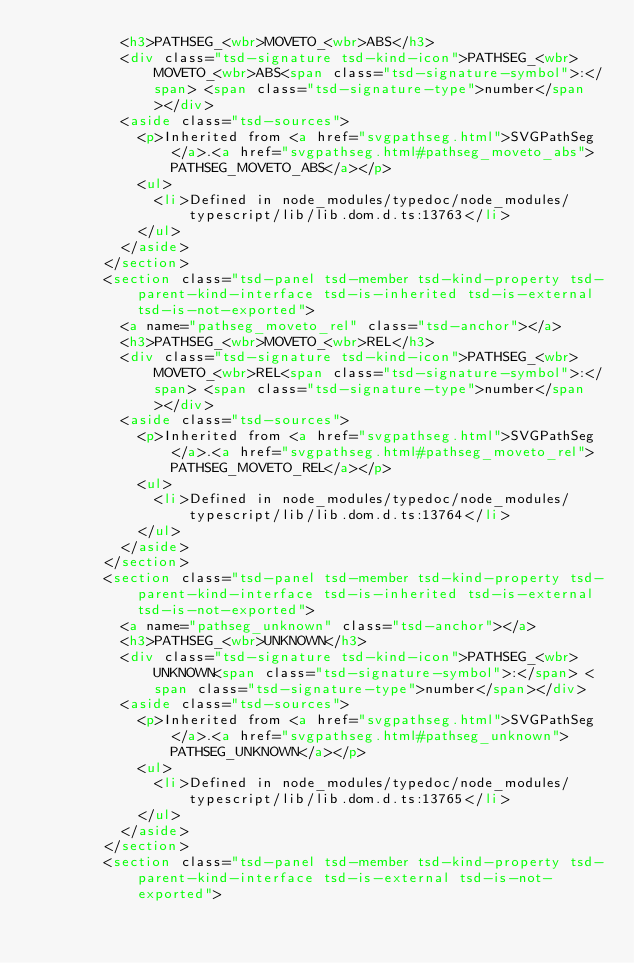Convert code to text. <code><loc_0><loc_0><loc_500><loc_500><_HTML_>					<h3>PATHSEG_<wbr>MOVETO_<wbr>ABS</h3>
					<div class="tsd-signature tsd-kind-icon">PATHSEG_<wbr>MOVETO_<wbr>ABS<span class="tsd-signature-symbol">:</span> <span class="tsd-signature-type">number</span></div>
					<aside class="tsd-sources">
						<p>Inherited from <a href="svgpathseg.html">SVGPathSeg</a>.<a href="svgpathseg.html#pathseg_moveto_abs">PATHSEG_MOVETO_ABS</a></p>
						<ul>
							<li>Defined in node_modules/typedoc/node_modules/typescript/lib/lib.dom.d.ts:13763</li>
						</ul>
					</aside>
				</section>
				<section class="tsd-panel tsd-member tsd-kind-property tsd-parent-kind-interface tsd-is-inherited tsd-is-external tsd-is-not-exported">
					<a name="pathseg_moveto_rel" class="tsd-anchor"></a>
					<h3>PATHSEG_<wbr>MOVETO_<wbr>REL</h3>
					<div class="tsd-signature tsd-kind-icon">PATHSEG_<wbr>MOVETO_<wbr>REL<span class="tsd-signature-symbol">:</span> <span class="tsd-signature-type">number</span></div>
					<aside class="tsd-sources">
						<p>Inherited from <a href="svgpathseg.html">SVGPathSeg</a>.<a href="svgpathseg.html#pathseg_moveto_rel">PATHSEG_MOVETO_REL</a></p>
						<ul>
							<li>Defined in node_modules/typedoc/node_modules/typescript/lib/lib.dom.d.ts:13764</li>
						</ul>
					</aside>
				</section>
				<section class="tsd-panel tsd-member tsd-kind-property tsd-parent-kind-interface tsd-is-inherited tsd-is-external tsd-is-not-exported">
					<a name="pathseg_unknown" class="tsd-anchor"></a>
					<h3>PATHSEG_<wbr>UNKNOWN</h3>
					<div class="tsd-signature tsd-kind-icon">PATHSEG_<wbr>UNKNOWN<span class="tsd-signature-symbol">:</span> <span class="tsd-signature-type">number</span></div>
					<aside class="tsd-sources">
						<p>Inherited from <a href="svgpathseg.html">SVGPathSeg</a>.<a href="svgpathseg.html#pathseg_unknown">PATHSEG_UNKNOWN</a></p>
						<ul>
							<li>Defined in node_modules/typedoc/node_modules/typescript/lib/lib.dom.d.ts:13765</li>
						</ul>
					</aside>
				</section>
				<section class="tsd-panel tsd-member tsd-kind-property tsd-parent-kind-interface tsd-is-external tsd-is-not-exported"></code> 